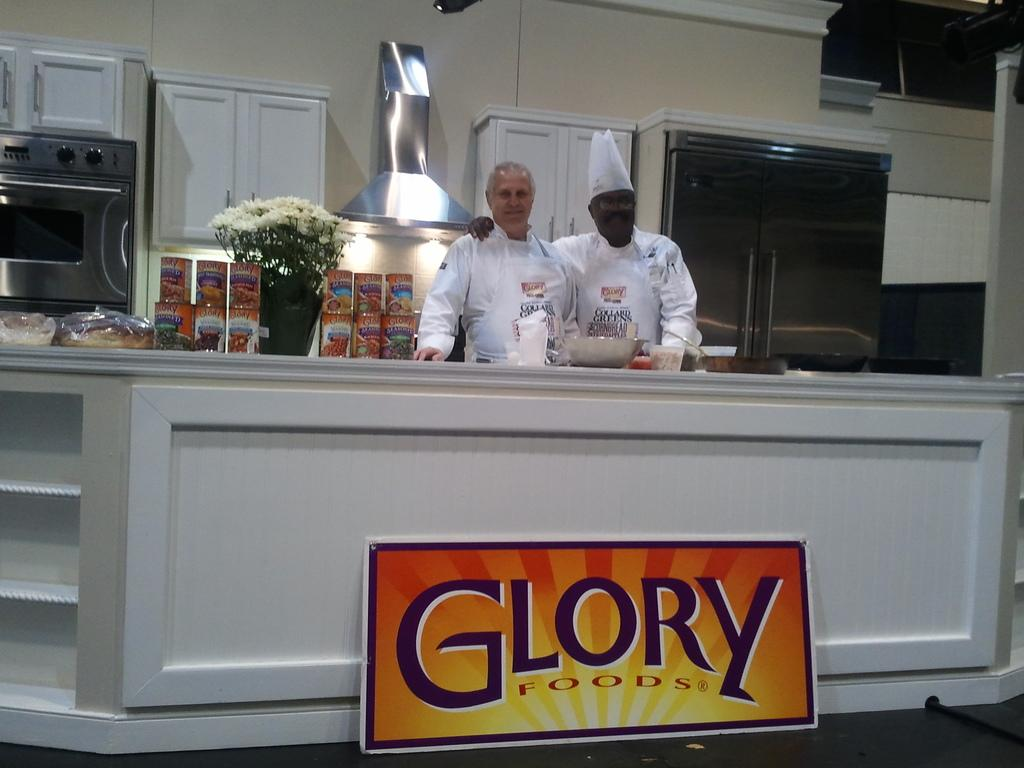<image>
Present a compact description of the photo's key features. Two men behind a counter with a sign saying Glory Foods 